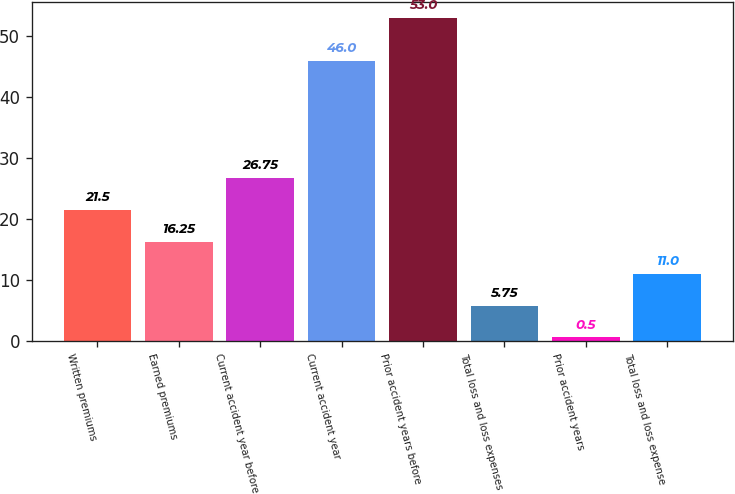Convert chart. <chart><loc_0><loc_0><loc_500><loc_500><bar_chart><fcel>Written premiums<fcel>Earned premiums<fcel>Current accident year before<fcel>Current accident year<fcel>Prior accident years before<fcel>Total loss and loss expenses<fcel>Prior accident years<fcel>Total loss and loss expense<nl><fcel>21.5<fcel>16.25<fcel>26.75<fcel>46<fcel>53<fcel>5.75<fcel>0.5<fcel>11<nl></chart> 